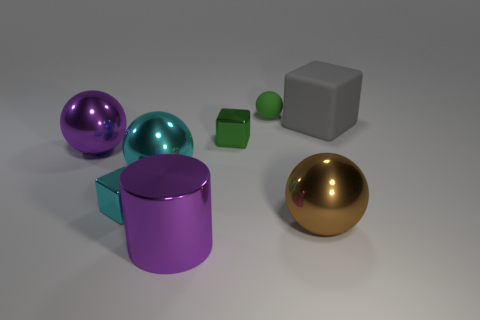Are there any other things that are the same material as the large purple ball?
Provide a short and direct response. Yes. Is the matte block the same color as the large metal cylinder?
Make the answer very short. No. How many other balls have the same material as the large cyan sphere?
Make the answer very short. 2. Are there fewer cyan blocks on the left side of the large purple metal sphere than blue things?
Ensure brevity in your answer.  No. There is a purple metal thing to the right of the large purple sphere on the left side of the gray rubber thing; how big is it?
Your response must be concise. Large. There is a big cylinder; is it the same color as the object that is behind the gray rubber block?
Offer a very short reply. No. There is a cube that is the same size as the green metallic thing; what is its material?
Keep it short and to the point. Metal. Are there fewer brown shiny things that are to the left of the tiny green rubber thing than tiny cyan shiny blocks left of the large purple sphere?
Make the answer very short. No. There is a big purple metal thing behind the purple metallic thing that is on the right side of the purple shiny sphere; what is its shape?
Provide a succinct answer. Sphere. Is there a big purple metal cylinder?
Give a very brief answer. Yes. 